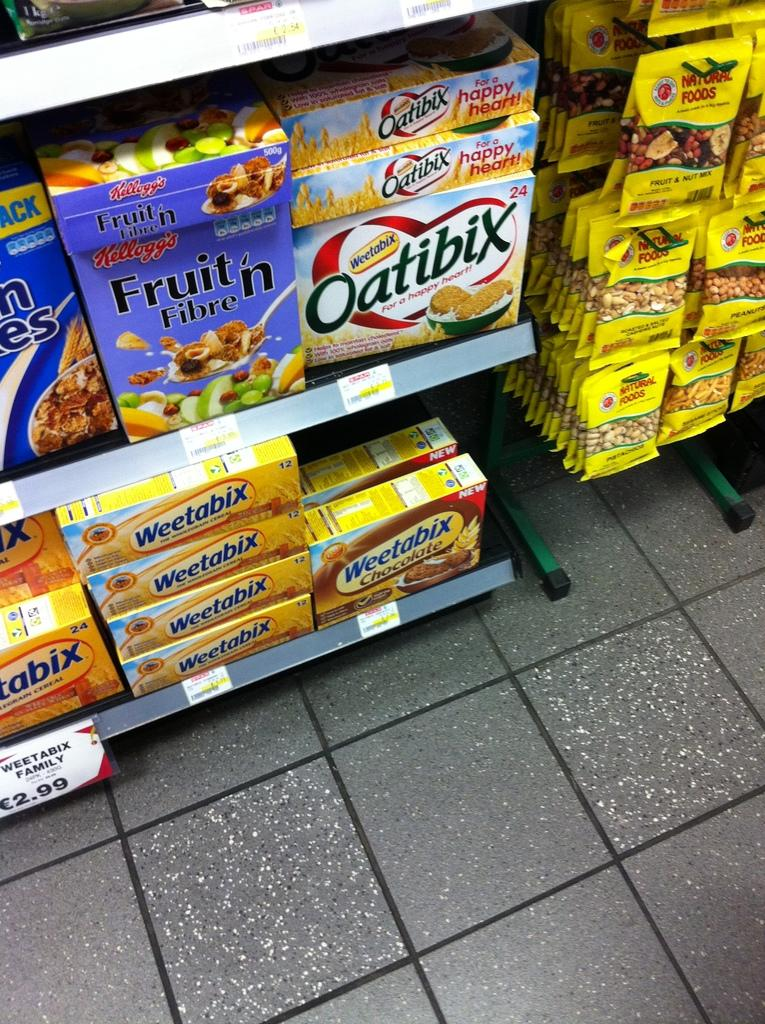Provide a one-sentence caption for the provided image. A convenience store with a cereal aisle that has Oatibix. 